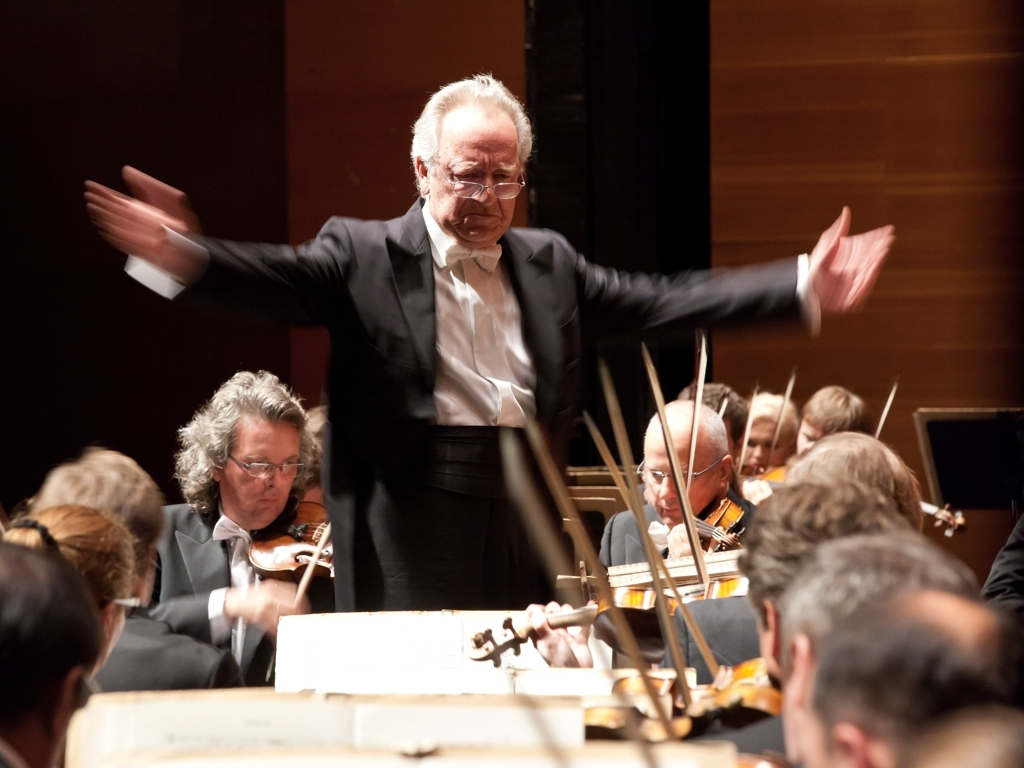What does the focusing issue result in?
A. Smoothing effect on the subject's hands
B. Significant motion blur in the subject's hands
C. Clear details in the subject's hands
D. Sharpness in the subject's hands Based on the image provided, it appears that the subject's hands are captured with a significant motion blur. This is likely due to the rapid movement of the conductor's hands during a performance, thus the correct answer to the question is option B. Capturing such a dynamic moment often results in this kind of blur, giving a sense of movement and activity in the photograph. 